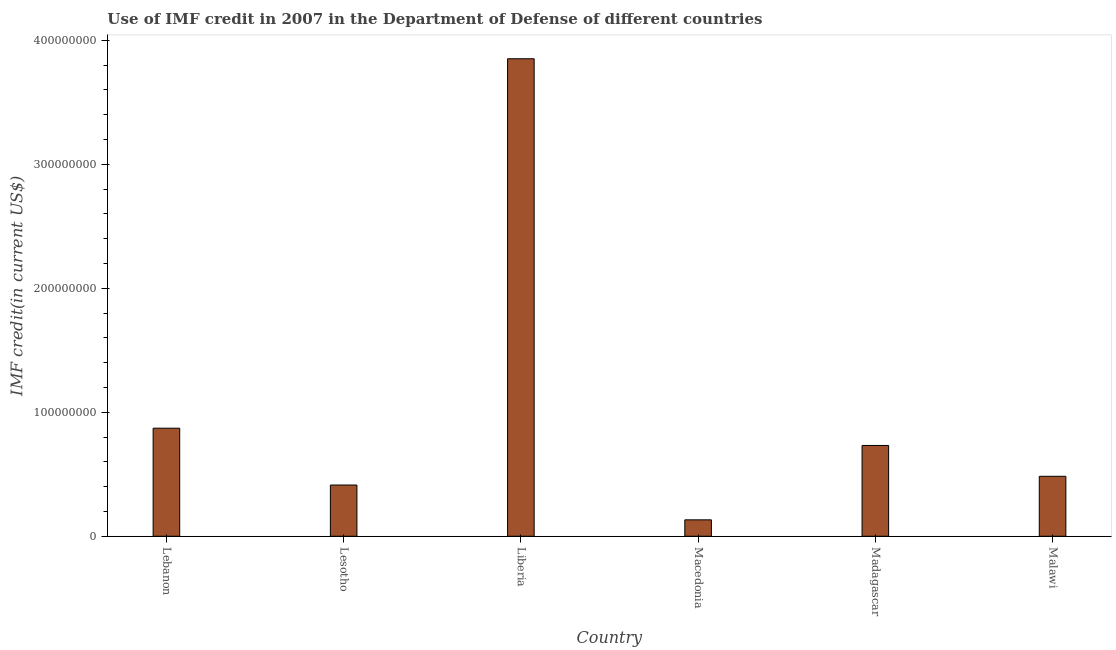What is the title of the graph?
Ensure brevity in your answer.  Use of IMF credit in 2007 in the Department of Defense of different countries. What is the label or title of the X-axis?
Provide a short and direct response. Country. What is the label or title of the Y-axis?
Keep it short and to the point. IMF credit(in current US$). What is the use of imf credit in dod in Liberia?
Your answer should be compact. 3.85e+08. Across all countries, what is the maximum use of imf credit in dod?
Your response must be concise. 3.85e+08. Across all countries, what is the minimum use of imf credit in dod?
Provide a short and direct response. 1.32e+07. In which country was the use of imf credit in dod maximum?
Offer a terse response. Liberia. In which country was the use of imf credit in dod minimum?
Keep it short and to the point. Macedonia. What is the sum of the use of imf credit in dod?
Provide a succinct answer. 6.48e+08. What is the difference between the use of imf credit in dod in Lebanon and Macedonia?
Make the answer very short. 7.39e+07. What is the average use of imf credit in dod per country?
Offer a terse response. 1.08e+08. What is the median use of imf credit in dod?
Offer a terse response. 6.08e+07. What is the ratio of the use of imf credit in dod in Lebanon to that in Malawi?
Provide a succinct answer. 1.8. What is the difference between the highest and the second highest use of imf credit in dod?
Ensure brevity in your answer.  2.98e+08. What is the difference between the highest and the lowest use of imf credit in dod?
Ensure brevity in your answer.  3.72e+08. In how many countries, is the use of imf credit in dod greater than the average use of imf credit in dod taken over all countries?
Provide a short and direct response. 1. How many bars are there?
Make the answer very short. 6. How many countries are there in the graph?
Your answer should be very brief. 6. What is the difference between two consecutive major ticks on the Y-axis?
Keep it short and to the point. 1.00e+08. Are the values on the major ticks of Y-axis written in scientific E-notation?
Ensure brevity in your answer.  No. What is the IMF credit(in current US$) of Lebanon?
Offer a terse response. 8.71e+07. What is the IMF credit(in current US$) of Lesotho?
Give a very brief answer. 4.13e+07. What is the IMF credit(in current US$) in Liberia?
Your answer should be very brief. 3.85e+08. What is the IMF credit(in current US$) in Macedonia?
Offer a terse response. 1.32e+07. What is the IMF credit(in current US$) in Madagascar?
Provide a succinct answer. 7.32e+07. What is the IMF credit(in current US$) of Malawi?
Keep it short and to the point. 4.83e+07. What is the difference between the IMF credit(in current US$) in Lebanon and Lesotho?
Offer a very short reply. 4.58e+07. What is the difference between the IMF credit(in current US$) in Lebanon and Liberia?
Give a very brief answer. -2.98e+08. What is the difference between the IMF credit(in current US$) in Lebanon and Macedonia?
Offer a terse response. 7.39e+07. What is the difference between the IMF credit(in current US$) in Lebanon and Madagascar?
Your answer should be very brief. 1.39e+07. What is the difference between the IMF credit(in current US$) in Lebanon and Malawi?
Your answer should be compact. 3.88e+07. What is the difference between the IMF credit(in current US$) in Lesotho and Liberia?
Your answer should be very brief. -3.44e+08. What is the difference between the IMF credit(in current US$) in Lesotho and Macedonia?
Keep it short and to the point. 2.81e+07. What is the difference between the IMF credit(in current US$) in Lesotho and Madagascar?
Your response must be concise. -3.19e+07. What is the difference between the IMF credit(in current US$) in Lesotho and Malawi?
Your response must be concise. -7.03e+06. What is the difference between the IMF credit(in current US$) in Liberia and Macedonia?
Your response must be concise. 3.72e+08. What is the difference between the IMF credit(in current US$) in Liberia and Madagascar?
Provide a short and direct response. 3.12e+08. What is the difference between the IMF credit(in current US$) in Liberia and Malawi?
Provide a succinct answer. 3.37e+08. What is the difference between the IMF credit(in current US$) in Macedonia and Madagascar?
Your response must be concise. -6.00e+07. What is the difference between the IMF credit(in current US$) in Macedonia and Malawi?
Your response must be concise. -3.51e+07. What is the difference between the IMF credit(in current US$) in Madagascar and Malawi?
Offer a terse response. 2.49e+07. What is the ratio of the IMF credit(in current US$) in Lebanon to that in Lesotho?
Provide a short and direct response. 2.11. What is the ratio of the IMF credit(in current US$) in Lebanon to that in Liberia?
Your answer should be very brief. 0.23. What is the ratio of the IMF credit(in current US$) in Lebanon to that in Macedonia?
Provide a short and direct response. 6.58. What is the ratio of the IMF credit(in current US$) in Lebanon to that in Madagascar?
Your answer should be very brief. 1.19. What is the ratio of the IMF credit(in current US$) in Lebanon to that in Malawi?
Offer a terse response. 1.8. What is the ratio of the IMF credit(in current US$) in Lesotho to that in Liberia?
Make the answer very short. 0.11. What is the ratio of the IMF credit(in current US$) in Lesotho to that in Macedonia?
Your response must be concise. 3.12. What is the ratio of the IMF credit(in current US$) in Lesotho to that in Madagascar?
Your answer should be compact. 0.56. What is the ratio of the IMF credit(in current US$) in Lesotho to that in Malawi?
Your answer should be compact. 0.85. What is the ratio of the IMF credit(in current US$) in Liberia to that in Macedonia?
Make the answer very short. 29.08. What is the ratio of the IMF credit(in current US$) in Liberia to that in Madagascar?
Offer a very short reply. 5.26. What is the ratio of the IMF credit(in current US$) in Liberia to that in Malawi?
Provide a succinct answer. 7.97. What is the ratio of the IMF credit(in current US$) in Macedonia to that in Madagascar?
Your answer should be very brief. 0.18. What is the ratio of the IMF credit(in current US$) in Macedonia to that in Malawi?
Offer a very short reply. 0.27. What is the ratio of the IMF credit(in current US$) in Madagascar to that in Malawi?
Your answer should be compact. 1.51. 